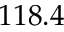<formula> <loc_0><loc_0><loc_500><loc_500>1 1 8 . 4</formula> 